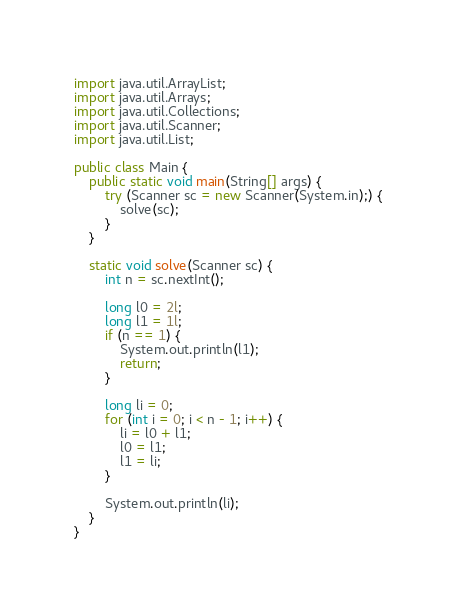<code> <loc_0><loc_0><loc_500><loc_500><_Java_>import java.util.ArrayList;
import java.util.Arrays;
import java.util.Collections;
import java.util.Scanner;
import java.util.List;

public class Main {
    public static void main(String[] args) {
        try (Scanner sc = new Scanner(System.in);) {
            solve(sc);
        }
    }

    static void solve(Scanner sc) {
        int n = sc.nextInt();

        long l0 = 2l;
        long l1 = 1l;
        if (n == 1) {
            System.out.println(l1);
            return;
        }

        long li = 0;
        for (int i = 0; i < n - 1; i++) {
            li = l0 + l1;
            l0 = l1;
            l1 = li;
        }

        System.out.println(li);
    }
}</code> 